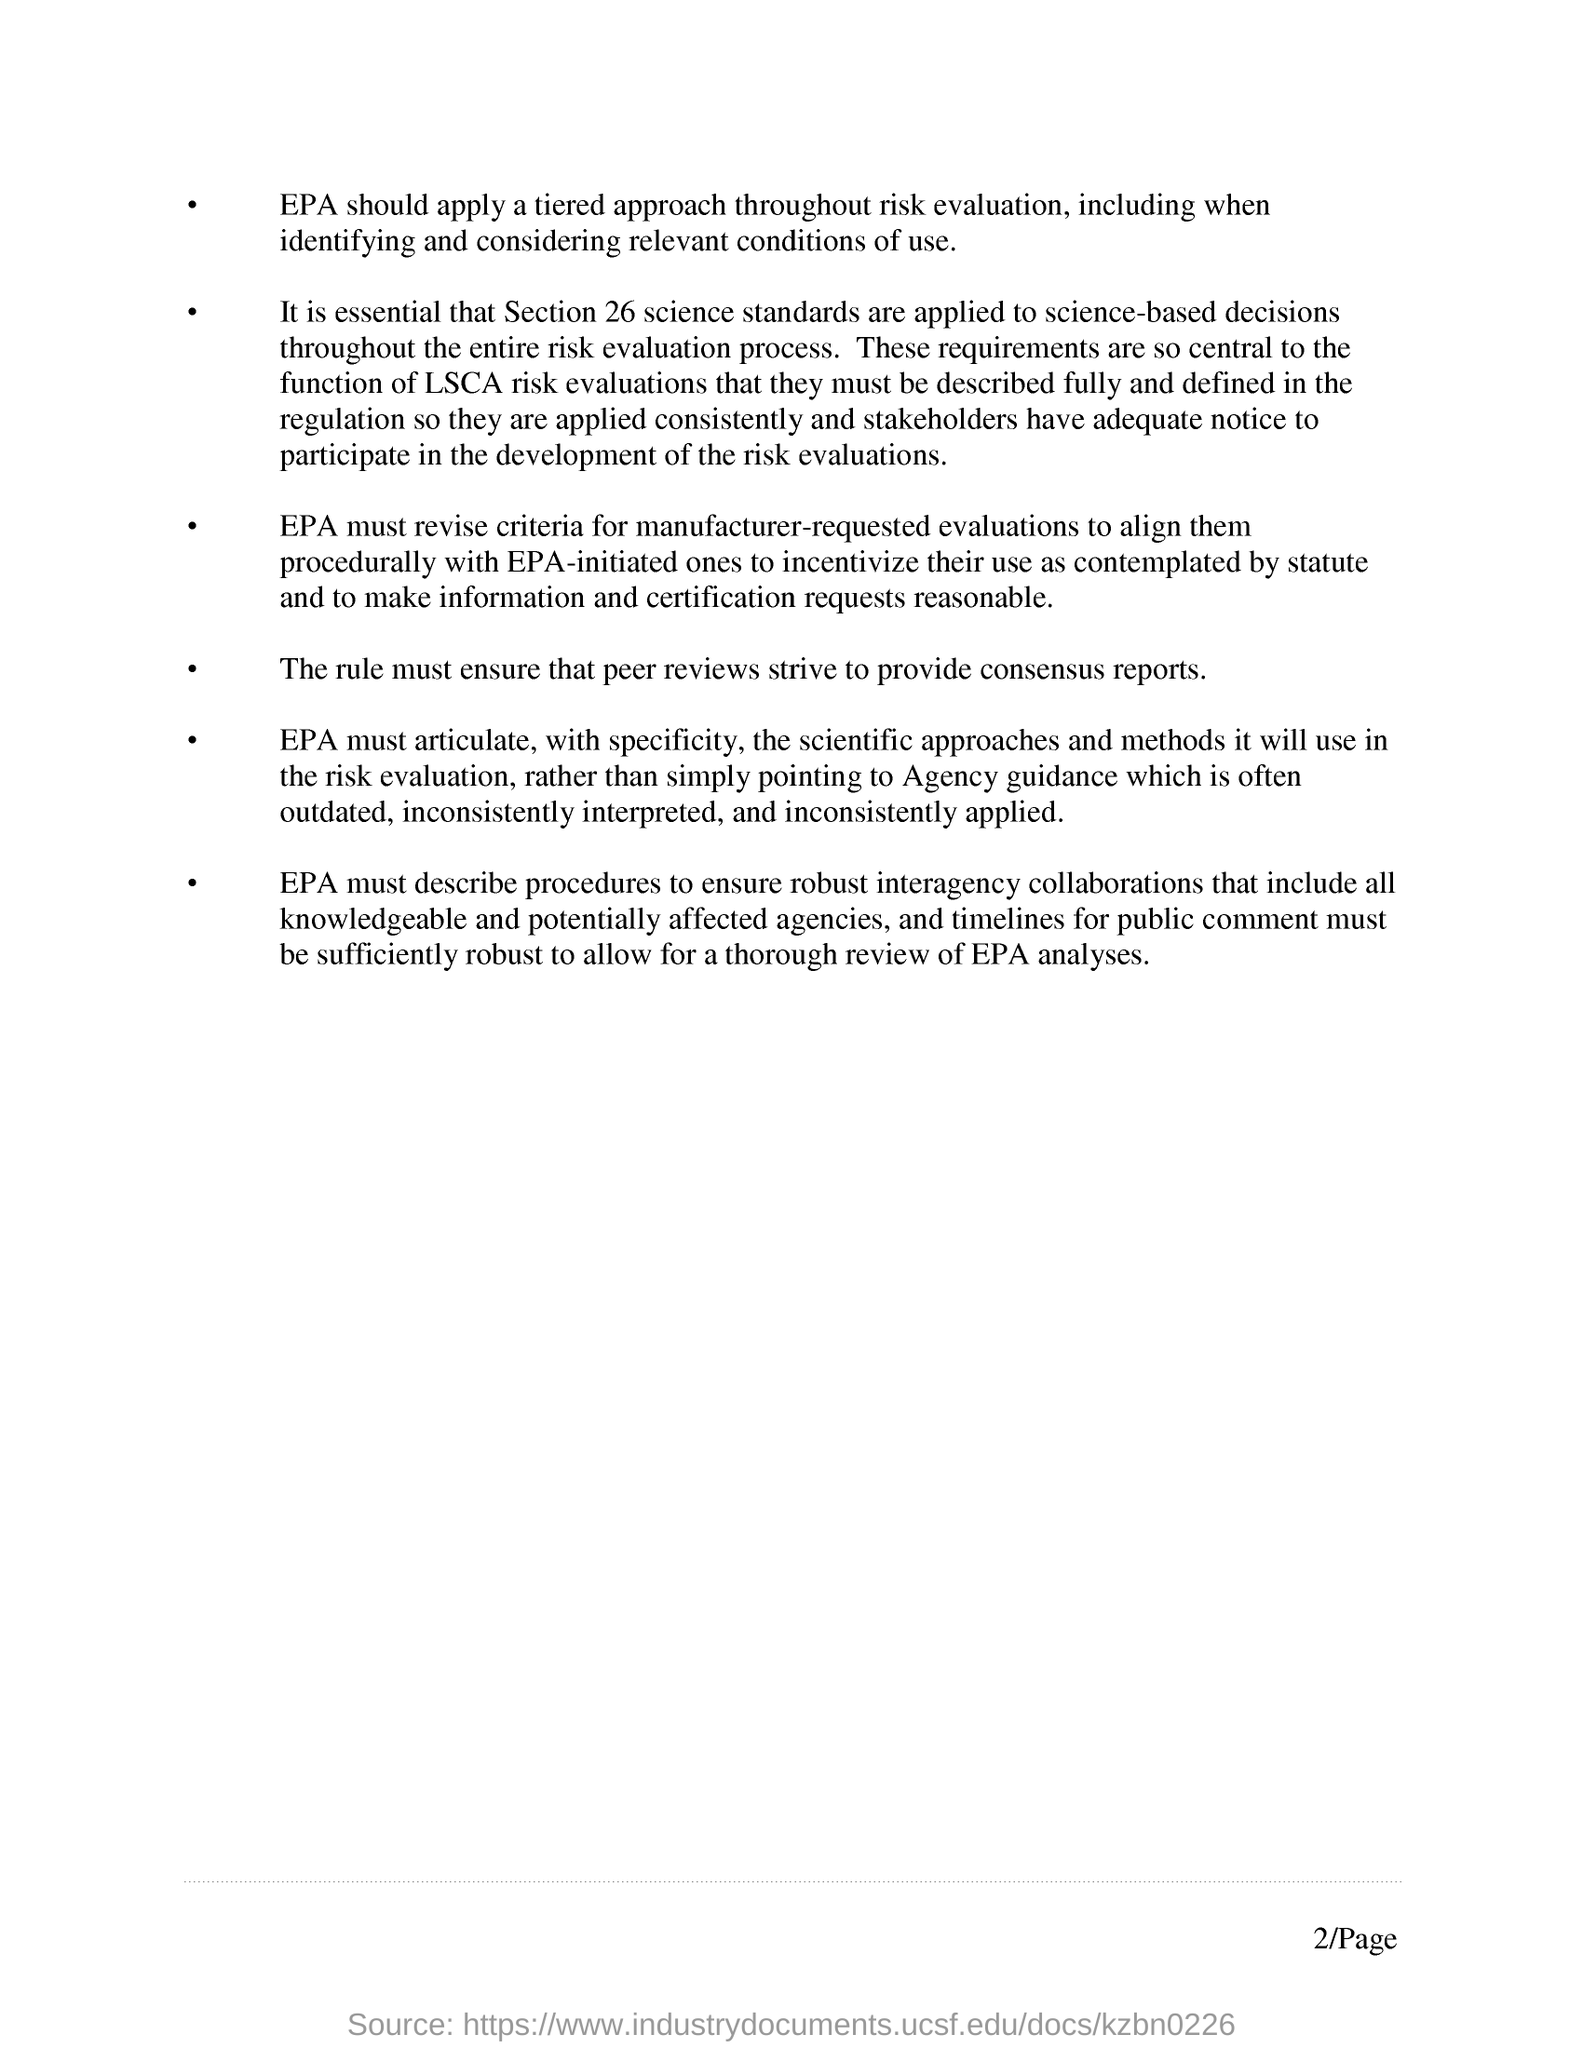What is the page no mentioned in this document?
Offer a terse response. 2. 